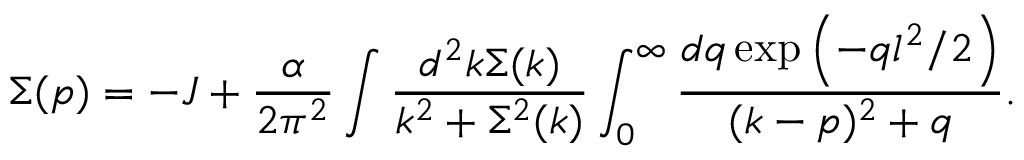Convert formula to latex. <formula><loc_0><loc_0><loc_500><loc_500>\Sigma ( p ) = - J + \frac { \alpha } { 2 \pi ^ { 2 } } \int \frac { d ^ { 2 } k \Sigma ( k ) } { k ^ { 2 } + \Sigma ^ { 2 } ( k ) } \int _ { 0 } ^ { \infty } \frac { d q \exp \left ( - q l ^ { 2 } / 2 \right ) } { ( k - p ) ^ { 2 } + q } .</formula> 